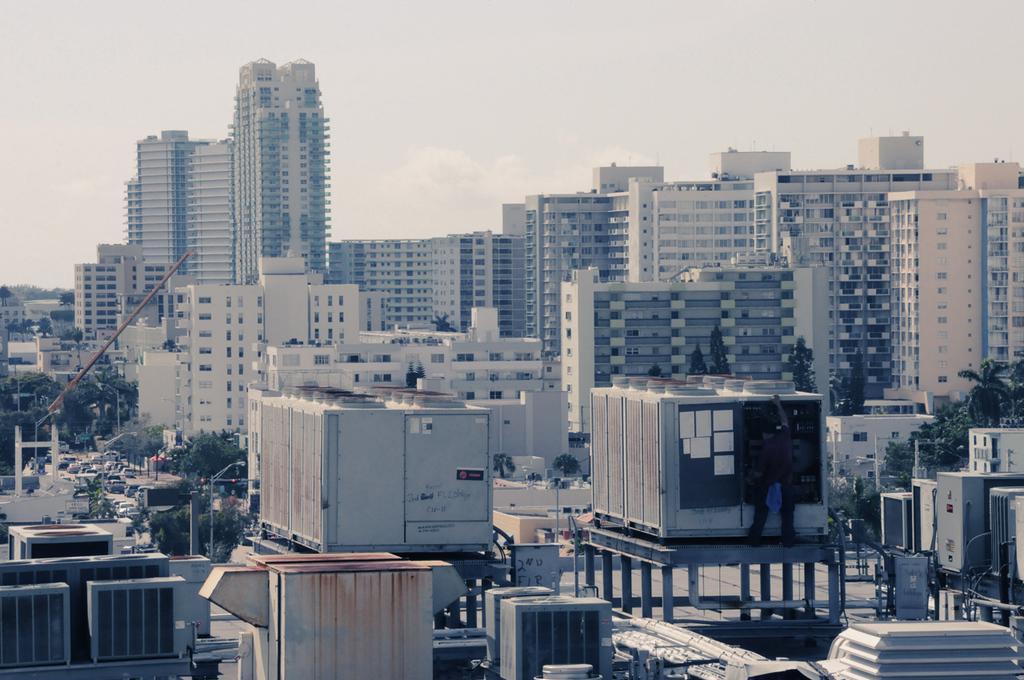How would you summarize this image in a sentence or two? In this image we can see buildings, trees, vehicles moving on the road and the cloudy sky in the background. 